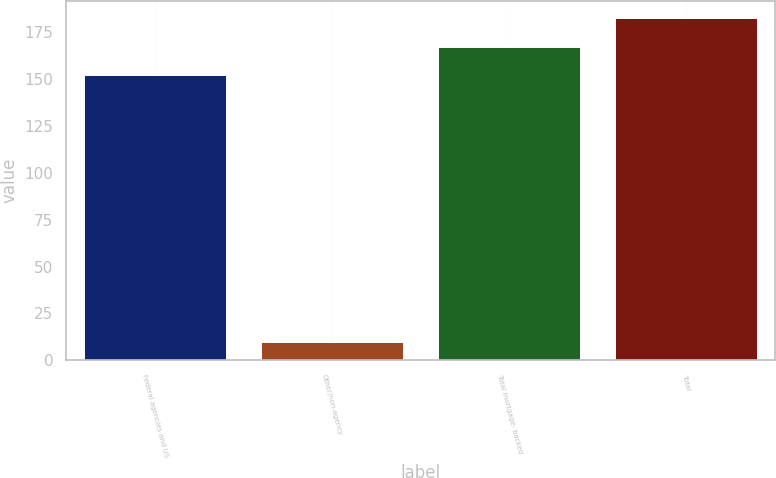Convert chart. <chart><loc_0><loc_0><loc_500><loc_500><bar_chart><fcel>Federal agencies and US<fcel>Other/non-agency<fcel>Total mortgage- backed<fcel>Total<nl><fcel>152<fcel>10<fcel>167.2<fcel>182.4<nl></chart> 